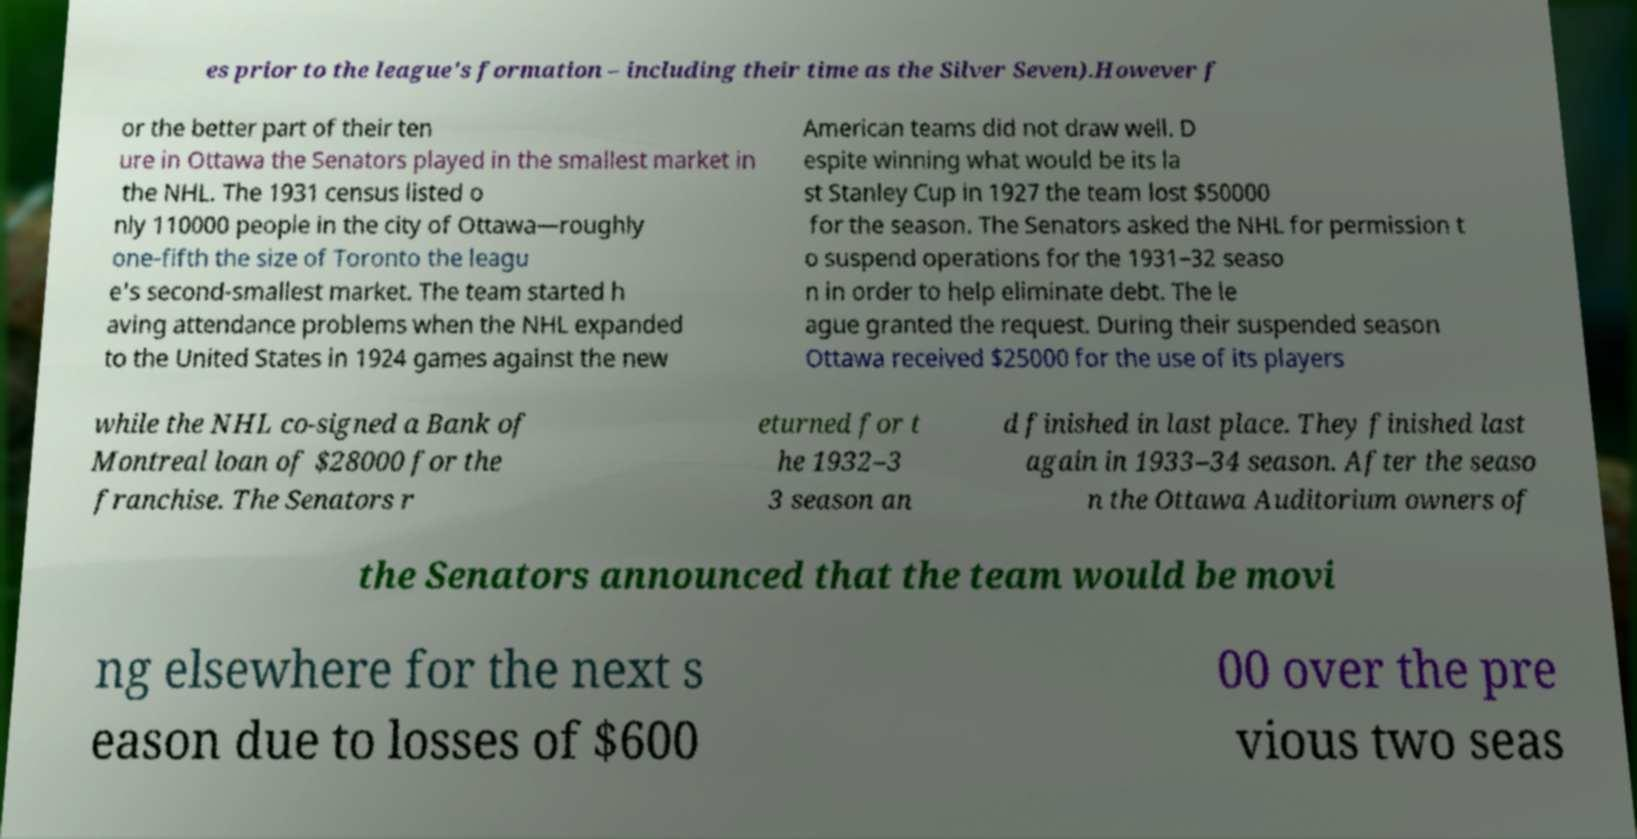What messages or text are displayed in this image? I need them in a readable, typed format. es prior to the league's formation – including their time as the Silver Seven).However f or the better part of their ten ure in Ottawa the Senators played in the smallest market in the NHL. The 1931 census listed o nly 110000 people in the city of Ottawa—roughly one-fifth the size of Toronto the leagu e's second-smallest market. The team started h aving attendance problems when the NHL expanded to the United States in 1924 games against the new American teams did not draw well. D espite winning what would be its la st Stanley Cup in 1927 the team lost $50000 for the season. The Senators asked the NHL for permission t o suspend operations for the 1931–32 seaso n in order to help eliminate debt. The le ague granted the request. During their suspended season Ottawa received $25000 for the use of its players while the NHL co-signed a Bank of Montreal loan of $28000 for the franchise. The Senators r eturned for t he 1932–3 3 season an d finished in last place. They finished last again in 1933–34 season. After the seaso n the Ottawa Auditorium owners of the Senators announced that the team would be movi ng elsewhere for the next s eason due to losses of $600 00 over the pre vious two seas 